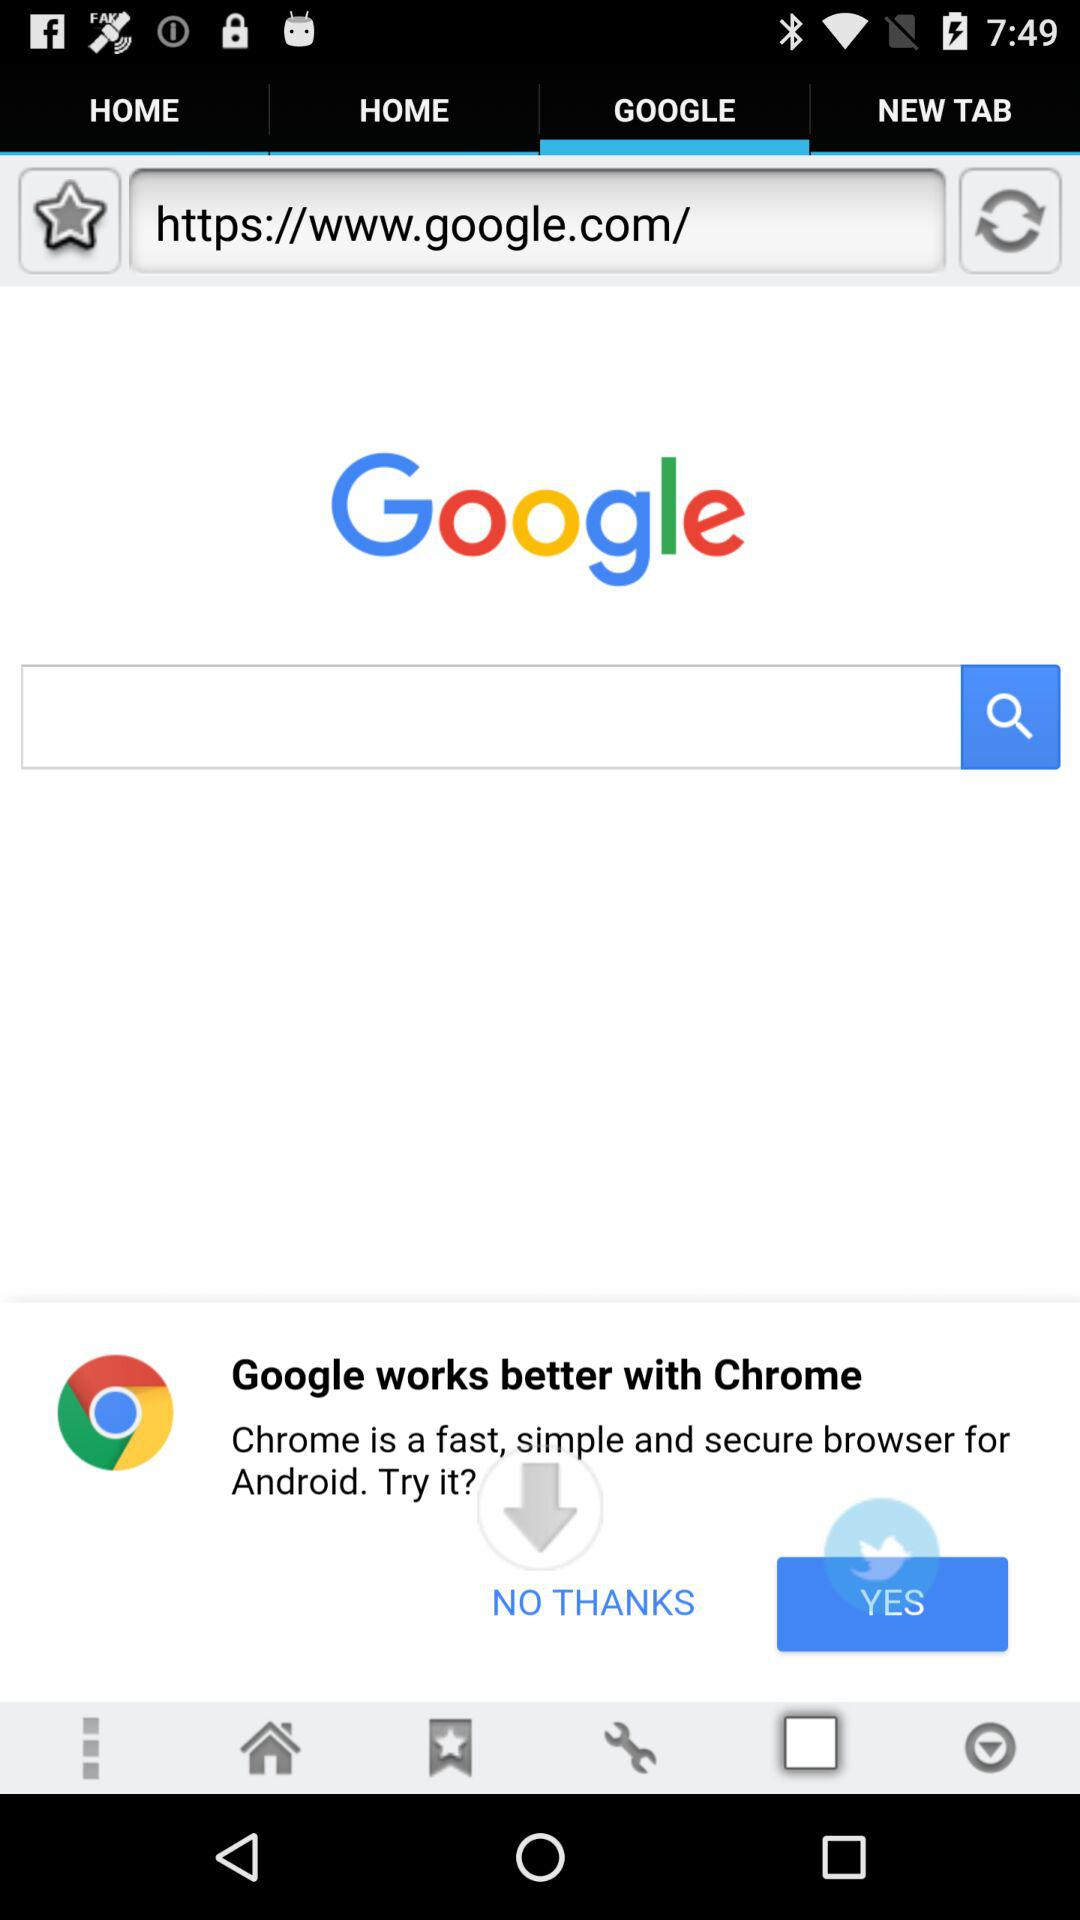Which tab is selected? The selected tab is "GOOGLE". 